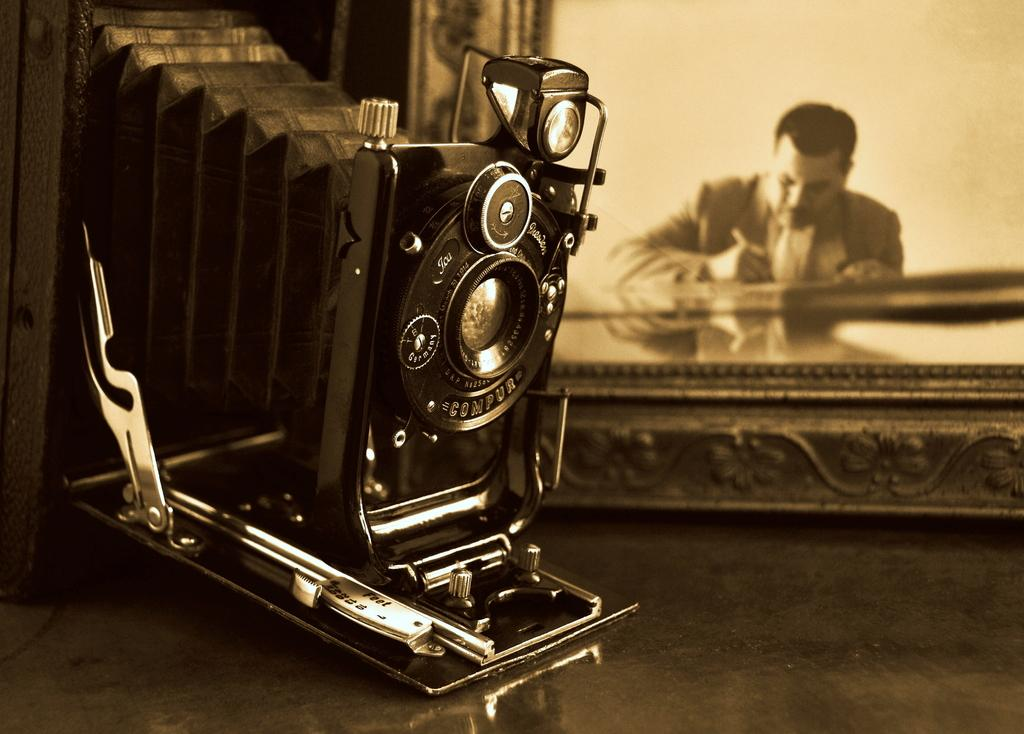What is happening in the image? There is a person in the image who is writing something. What else can be seen in the image? There is a camera present in the image. What type of quiver is the laborer carrying in the image? There is no laborer or quiver present in the image. What is the person using to write in the image? The facts provided do not specify the writing instrument used by the person in the image. 